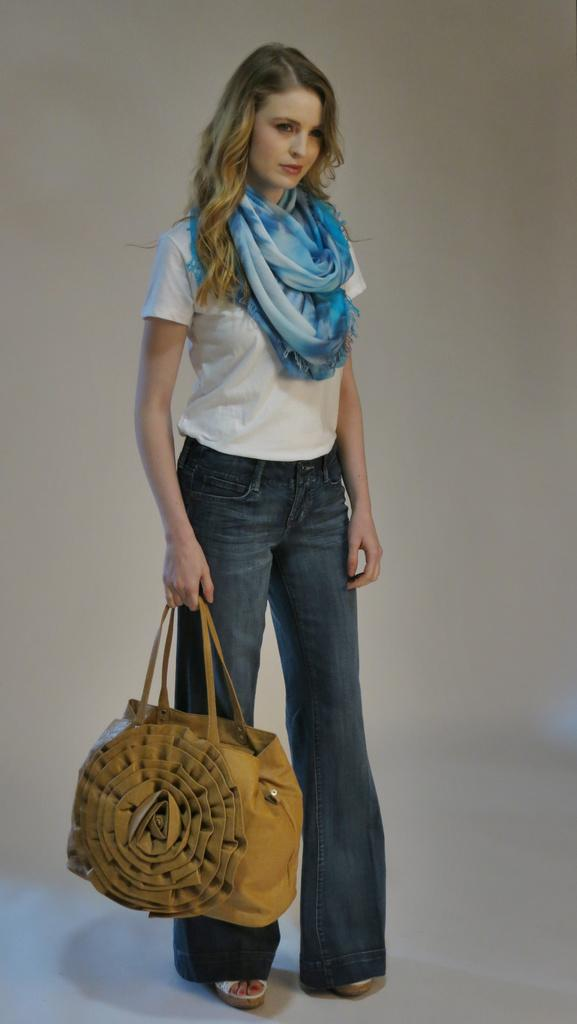Who is present in the image? There is a woman in the image. What is the woman doing in the image? The woman is standing in the image. What object is the woman holding in her hand? The woman is holding a handbag in her hand. What type of veil can be seen on the woman's head in the image? There is no veil present on the woman's head in the image. How many balls is the woman juggling in the image? There are no balls present in the image, and the woman is not juggling anything. 